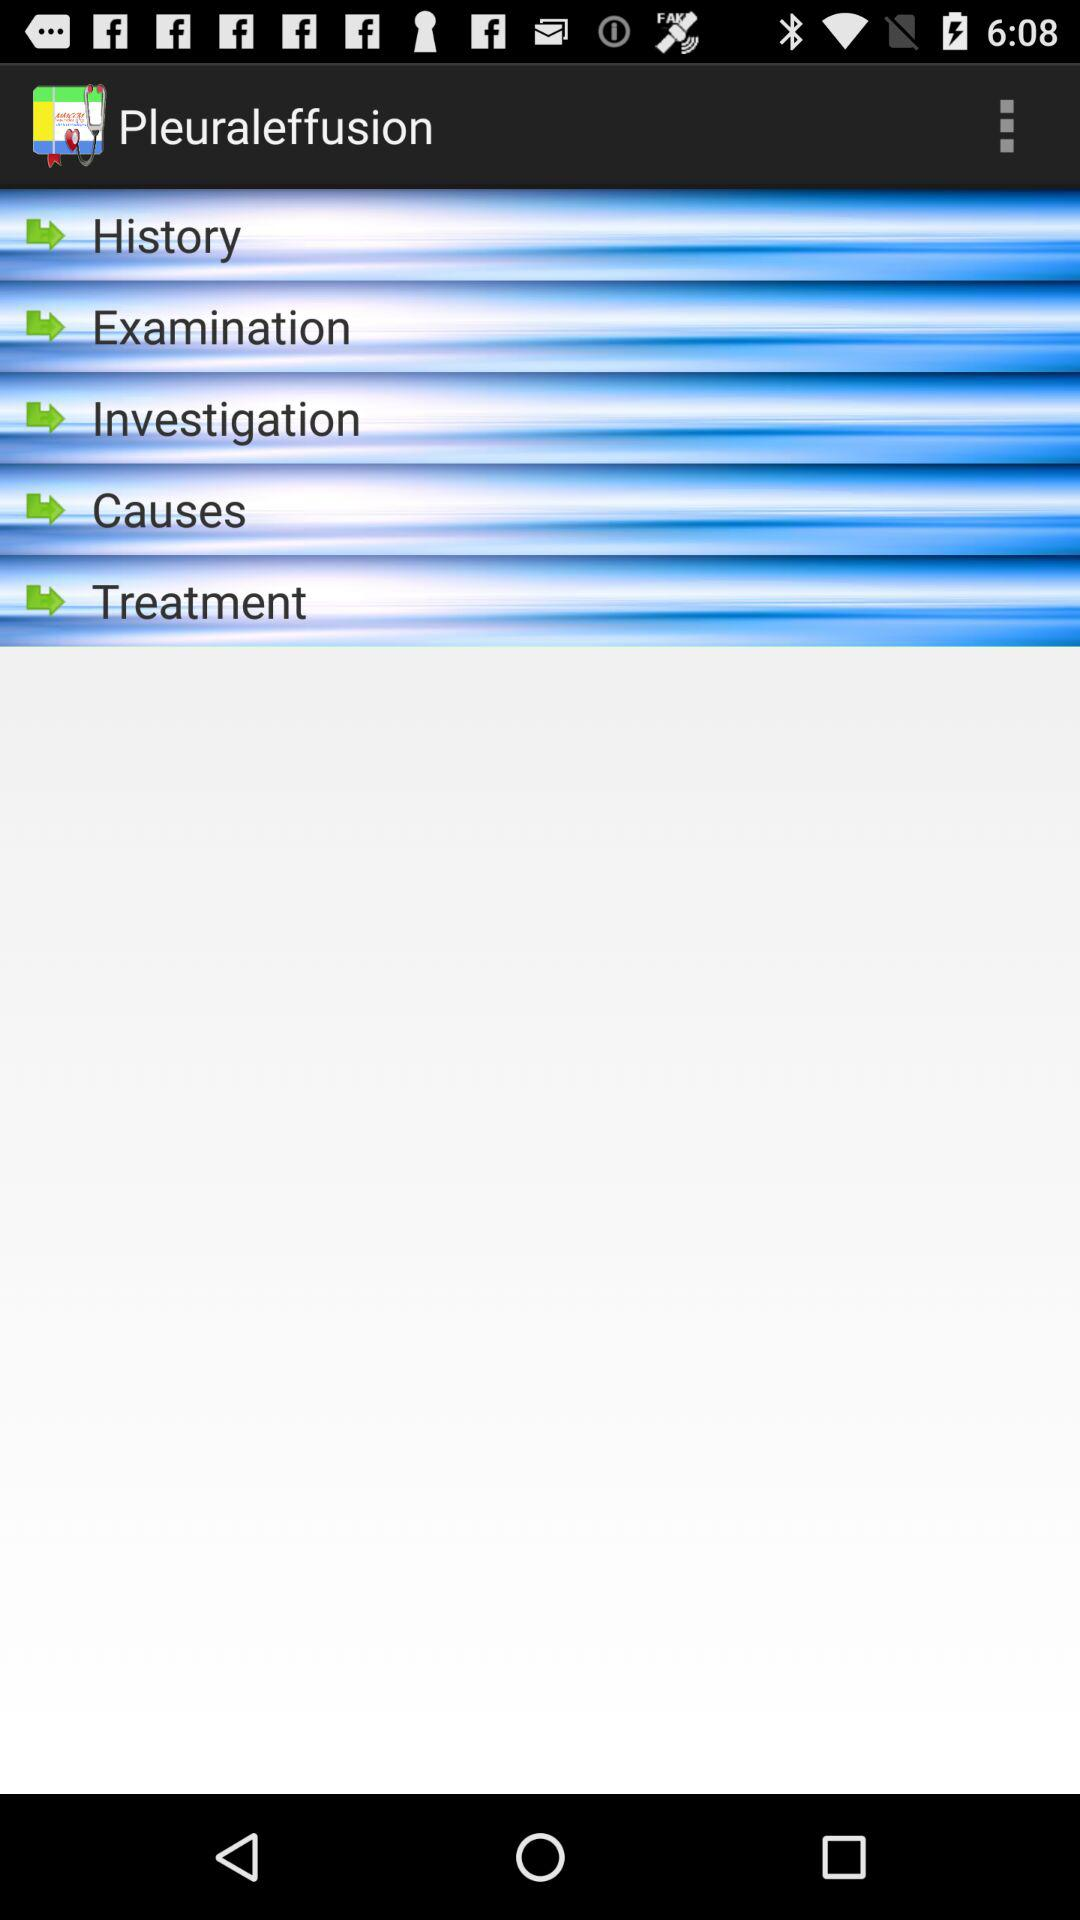What is the name of the application? The name of the application is "Pleuraleffusion". 